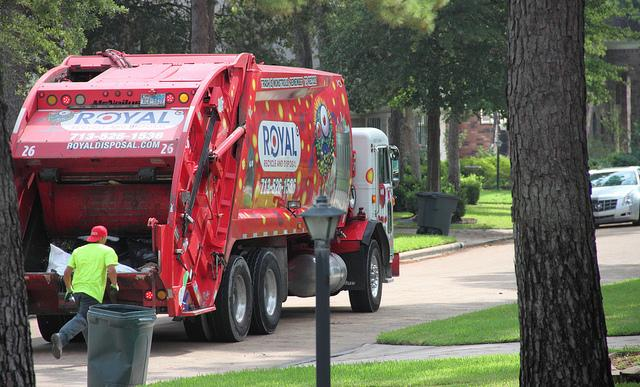What is being gathered by this vehicle? Please explain your reasoning. garbage. A man is standing at the back of a garbage truck on the street. 